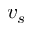Convert formula to latex. <formula><loc_0><loc_0><loc_500><loc_500>v _ { s }</formula> 